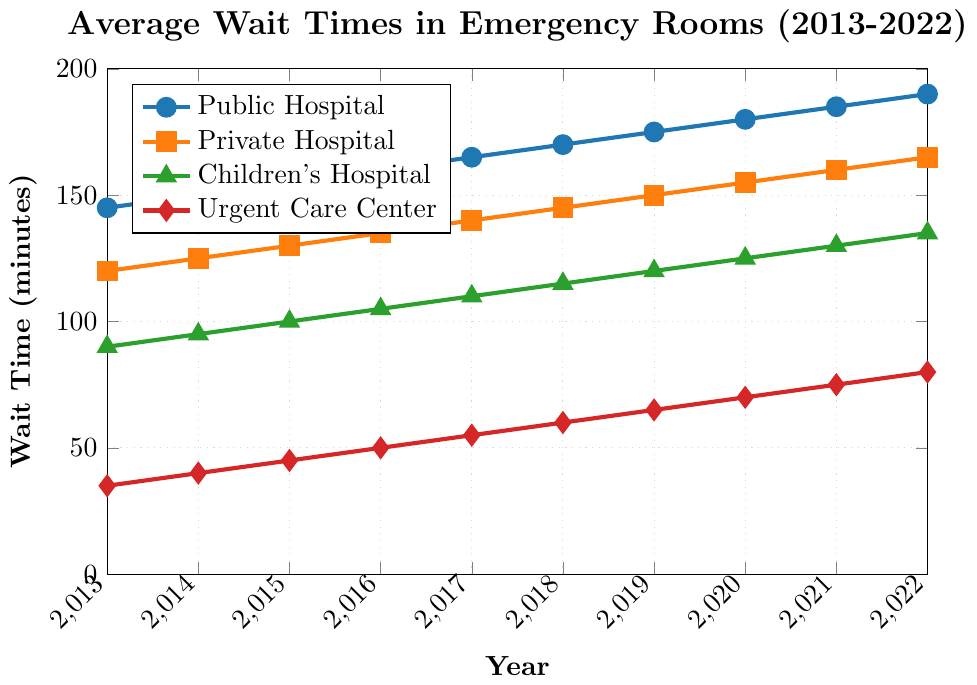What is the average wait time at Public Hospital for the year 2022? Look at the data point for year 2022 under Public Hospital. The wait time is 190 minutes.
Answer: 190 Which type of hospital had the shortest average wait time in 2016? Compare the wait times of all hospital types for the year 2016. Public Hospital is 160, Private Hospital is 135, Children's Hospital is 105, and Urgent Care Center is 50. The shortest wait time is at Urgent Care Center.
Answer: Urgent Care Center By how many minutes did the average wait time at Private Hospitals increase from 2013 to 2022? Subtract the wait time in 2013 (120 minutes) from the wait time in 2022 (165 minutes). The difference is 165 - 120 = 45 minutes.
Answer: 45 Which hospital type had the most consistent wait time increase over the years? Observe the slope of each line representing the hospital types. The Urgent Care Center has the most consistent linear increase compared to the other types.
Answer: Urgent Care Center In which year did the average wait time at Children's Hospital reach 100 minutes? Look at the data values for Children's Hospital. The wait time reached 100 minutes in 2015.
Answer: 2015 Compare the average wait times at Public Hospital and Children's Hospital in 2020. By how much is one higher or lower than the other? The wait time at Public Hospital in 2020 is 180 minutes, and at Children's Hospital it is 125 minutes. The difference is 180 - 125 = 55 minutes. Public Hospital's wait time is higher by 55 minutes.
Answer: 55 What is the total increase in wait times from 2013 to 2022 for Urgent Care Centers? Subtract the wait time in 2013 (35 minutes) from the wait time in 2022 (80 minutes). The increase is 80 - 35 = 45 minutes.
Answer: 45 Which color represents the Children's Hospital wait times on the chart? Look at the legend to identify the color linked to Children's Hospital wait times, which is green.
Answer: green How did the average wait time at Public Hospitals change between 2017 and 2018? Look at the data for Public Hospitals in 2017 (165 minutes) and in 2018 (170 minutes). The increase is 170 - 165 = 5 minutes.
Answer: 5 What is the difference in the average wait time between Urgent Care Centers and Private Hospitals in 2021? Look at the data for Urgent Care Centers (75 minutes) and Private Hospitals (160 minutes) in 2021. The difference is 160 - 75 = 85 minutes.
Answer: 85 